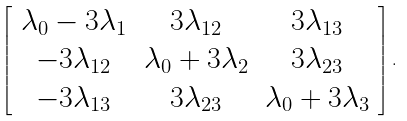<formula> <loc_0><loc_0><loc_500><loc_500>\left [ \begin{array} { c c c } \lambda _ { 0 } - 3 \lambda _ { 1 } & 3 \lambda _ { 1 2 } & 3 \lambda _ { 1 3 } \\ - 3 \lambda _ { 1 2 } & \lambda _ { 0 } + 3 \lambda _ { 2 } & 3 \lambda _ { 2 3 } \\ - 3 \lambda _ { 1 3 } & 3 \lambda _ { 2 3 } & \lambda _ { 0 } + 3 \lambda _ { 3 } \end{array} \right ] .</formula> 